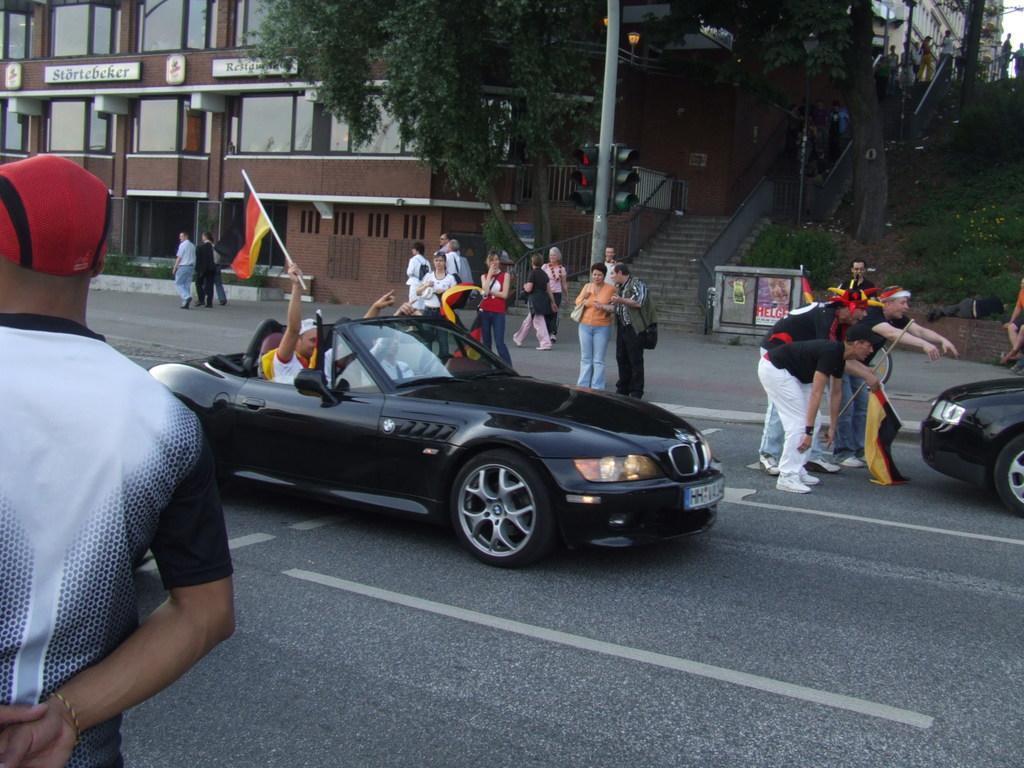Please provide a concise description of this image. In this picture there are two persons sitting in a black car which is on the road where one among them is holding a stick which has a flag attached to it and there are few persons,a car,traffic signals,a building and a tree beside him and there is a person standing in the left corner. 